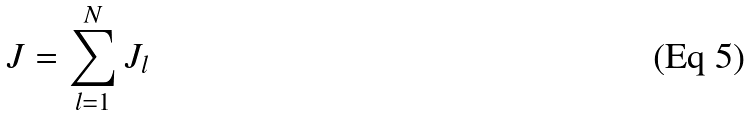<formula> <loc_0><loc_0><loc_500><loc_500>J = \sum _ { l = 1 } ^ { N } J _ { l }</formula> 